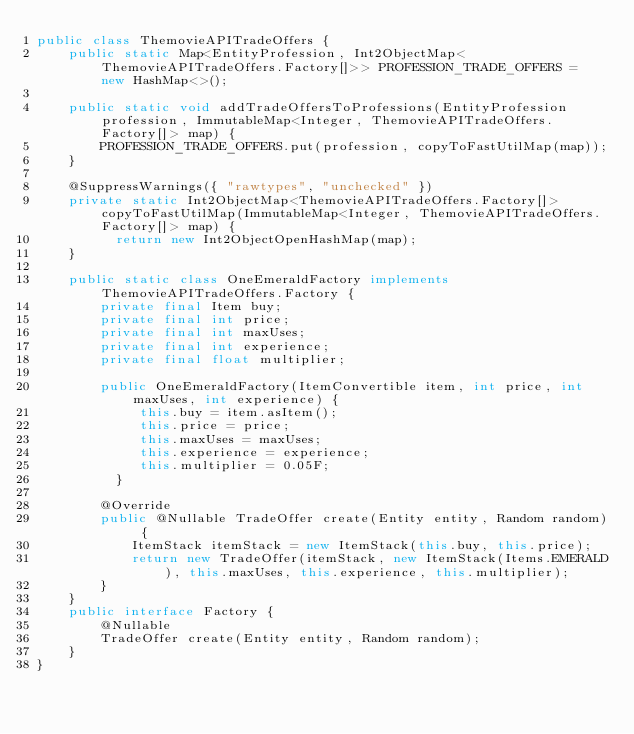<code> <loc_0><loc_0><loc_500><loc_500><_Java_>public class ThemovieAPITradeOffers {
	public static Map<EntityProfession, Int2ObjectMap<ThemovieAPITradeOffers.Factory[]>> PROFESSION_TRADE_OFFERS = new HashMap<>();
	
	public static void addTradeOffersToProfessions(EntityProfession profession, ImmutableMap<Integer, ThemovieAPITradeOffers.Factory[]> map) {
		PROFESSION_TRADE_OFFERS.put(profession, copyToFastUtilMap(map));
	}
	
	@SuppressWarnings({ "rawtypes", "unchecked" })
	private static Int2ObjectMap<ThemovieAPITradeOffers.Factory[]> copyToFastUtilMap(ImmutableMap<Integer, ThemovieAPITradeOffers.Factory[]> map) {
	      return new Int2ObjectOpenHashMap(map);
	}
	
	public static class OneEmeraldFactory implements ThemovieAPITradeOffers.Factory {
		private final Item buy;
		private final int price;
		private final int maxUses;
		private final int experience;
		private final float multiplier;
		
		public OneEmeraldFactory(ItemConvertible item, int price, int maxUses, int experience) {
	         this.buy = item.asItem();
	         this.price = price;
	         this.maxUses = maxUses;
	         this.experience = experience;
	         this.multiplier = 0.05F;
	      }
		
		@Override
		public @Nullable TradeOffer create(Entity entity, Random random) {
			ItemStack itemStack = new ItemStack(this.buy, this.price);
			return new TradeOffer(itemStack, new ItemStack(Items.EMERALD), this.maxUses, this.experience, this.multiplier);
		}
	}
	public interface Factory {
		@Nullable
		TradeOffer create(Entity entity, Random random);
	}
}
</code> 